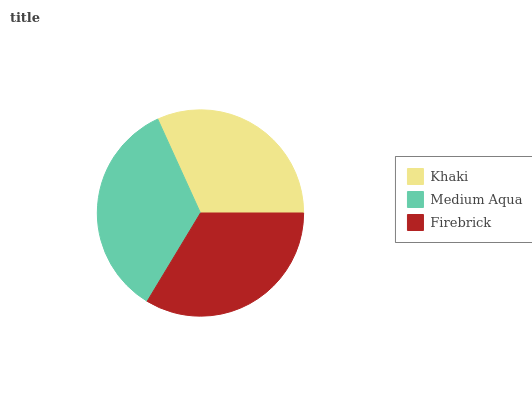Is Khaki the minimum?
Answer yes or no. Yes. Is Medium Aqua the maximum?
Answer yes or no. Yes. Is Firebrick the minimum?
Answer yes or no. No. Is Firebrick the maximum?
Answer yes or no. No. Is Medium Aqua greater than Firebrick?
Answer yes or no. Yes. Is Firebrick less than Medium Aqua?
Answer yes or no. Yes. Is Firebrick greater than Medium Aqua?
Answer yes or no. No. Is Medium Aqua less than Firebrick?
Answer yes or no. No. Is Firebrick the high median?
Answer yes or no. Yes. Is Firebrick the low median?
Answer yes or no. Yes. Is Khaki the high median?
Answer yes or no. No. Is Medium Aqua the low median?
Answer yes or no. No. 